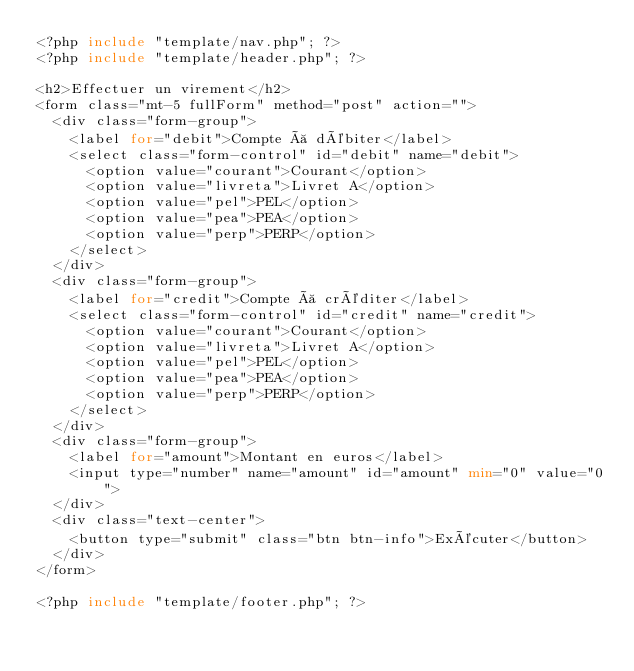<code> <loc_0><loc_0><loc_500><loc_500><_PHP_><?php include "template/nav.php"; ?>
<?php include "template/header.php"; ?>

<h2>Effectuer un virement</h2>
<form class="mt-5 fullForm" method="post" action="">
  <div class="form-group">
    <label for="debit">Compte à débiter</label>
    <select class="form-control" id="debit" name="debit">
      <option value="courant">Courant</option>
      <option value="livreta">Livret A</option>
      <option value="pel">PEL</option>
      <option value="pea">PEA</option>
      <option value="perp">PERP</option>
    </select>
  </div>
  <div class="form-group">
    <label for="credit">Compte à créditer</label>
    <select class="form-control" id="credit" name="credit">
      <option value="courant">Courant</option>
      <option value="livreta">Livret A</option>
      <option value="pel">PEL</option>
      <option value="pea">PEA</option>
      <option value="perp">PERP</option>
    </select>
  </div>
  <div class="form-group">
    <label for="amount">Montant en euros</label>
    <input type="number" name="amount" id="amount" min="0" value="0">
  </div>
  <div class="text-center">
    <button type="submit" class="btn btn-info">Exécuter</button>
  </div>
</form>

<?php include "template/footer.php"; ?>
</code> 